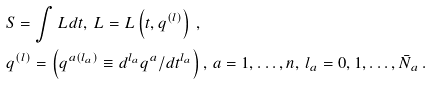<formula> <loc_0><loc_0><loc_500><loc_500>& S = \int L d t , \, L = L \left ( t , q ^ { \left ( l \right ) } \right ) \, , \\ & q ^ { \left ( l \right ) } = \left ( q ^ { a \left ( l _ { a } \right ) } \equiv d ^ { l _ { a } } q ^ { a } / d t ^ { l _ { a } } \right ) , \, a = 1 , \dots , n , \, l _ { a } = 0 , 1 , \dots , \bar { N } _ { a } \, .</formula> 